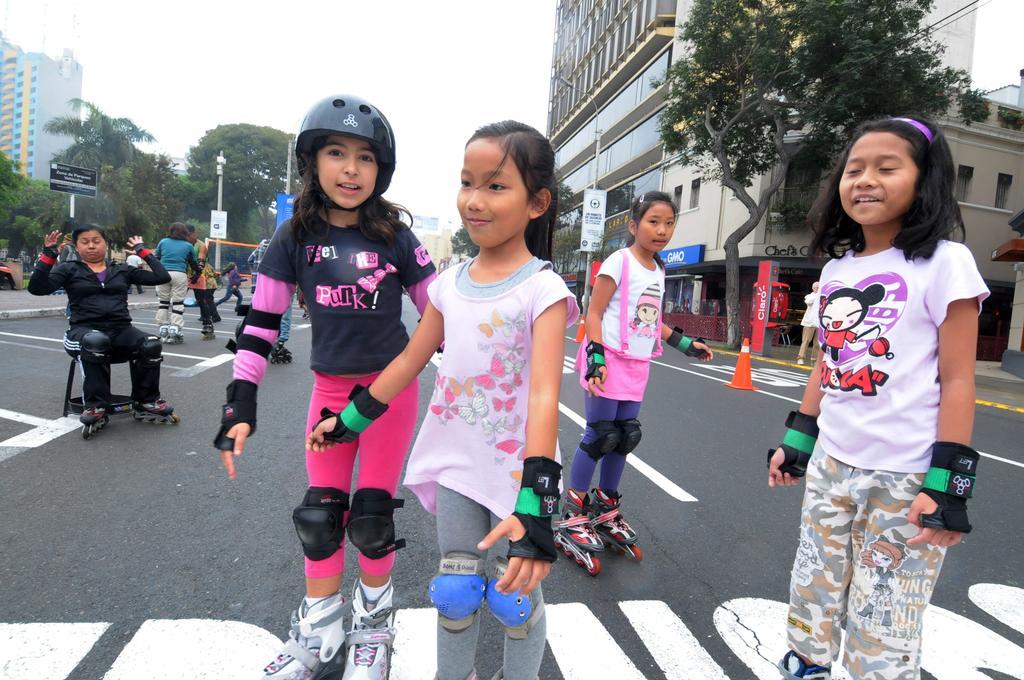Please provide a concise description of this image. In the foreground of this image, there are kids skating on the road and a woman in black dress sitting on a stool wearing skates. In the background, there are buildings, trees, poles, and the sky. 